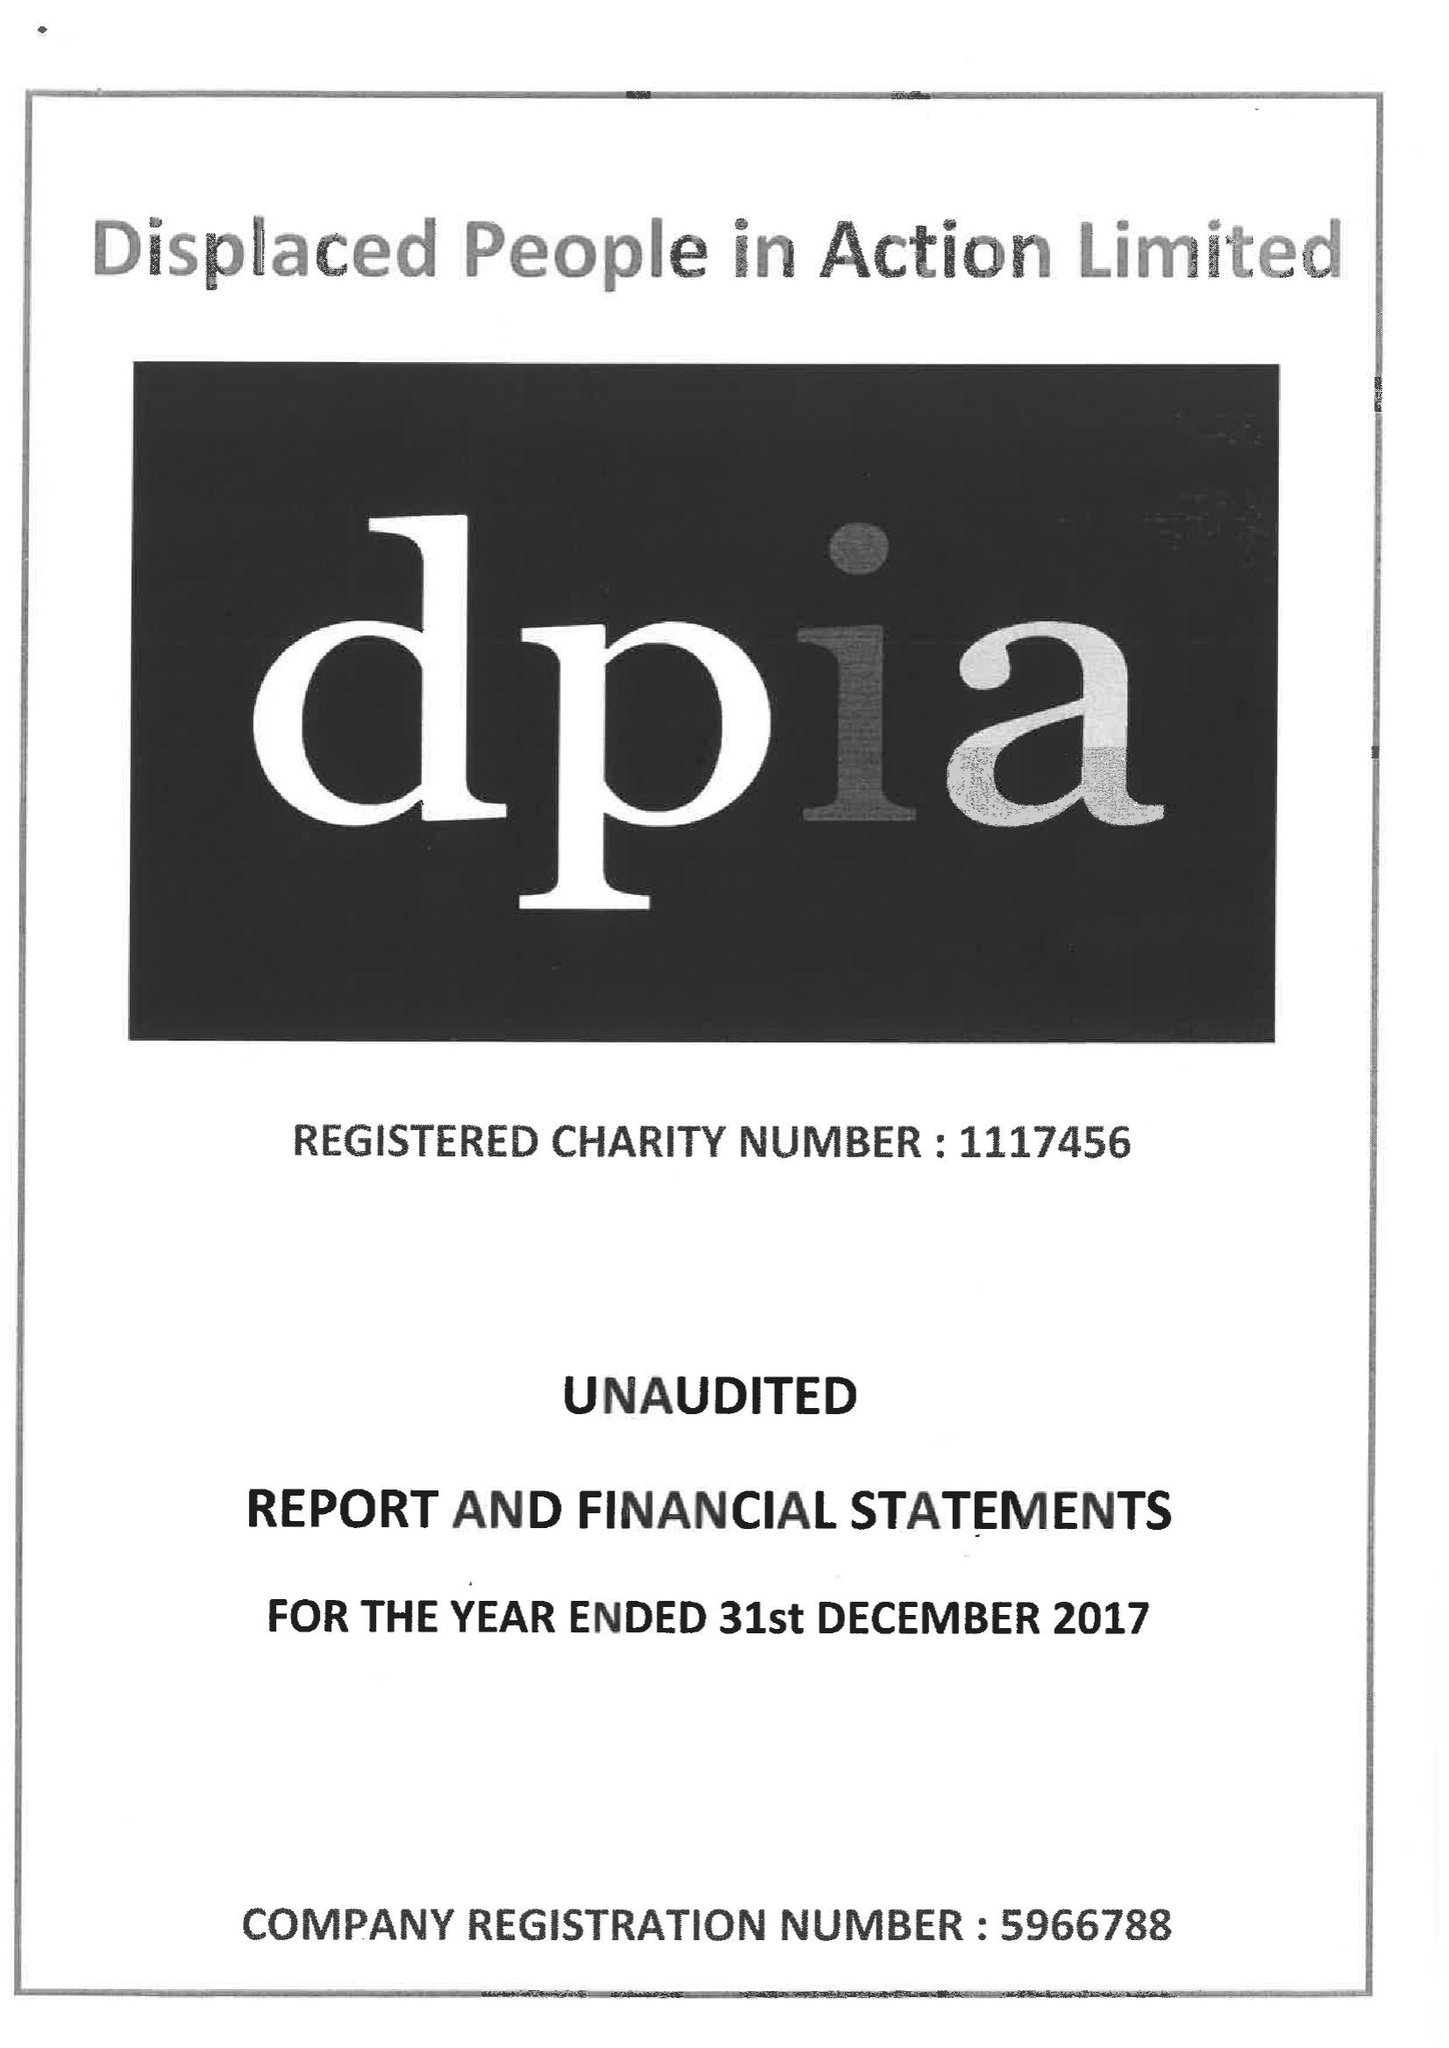What is the value for the income_annually_in_british_pounds?
Answer the question using a single word or phrase. 469280.00 